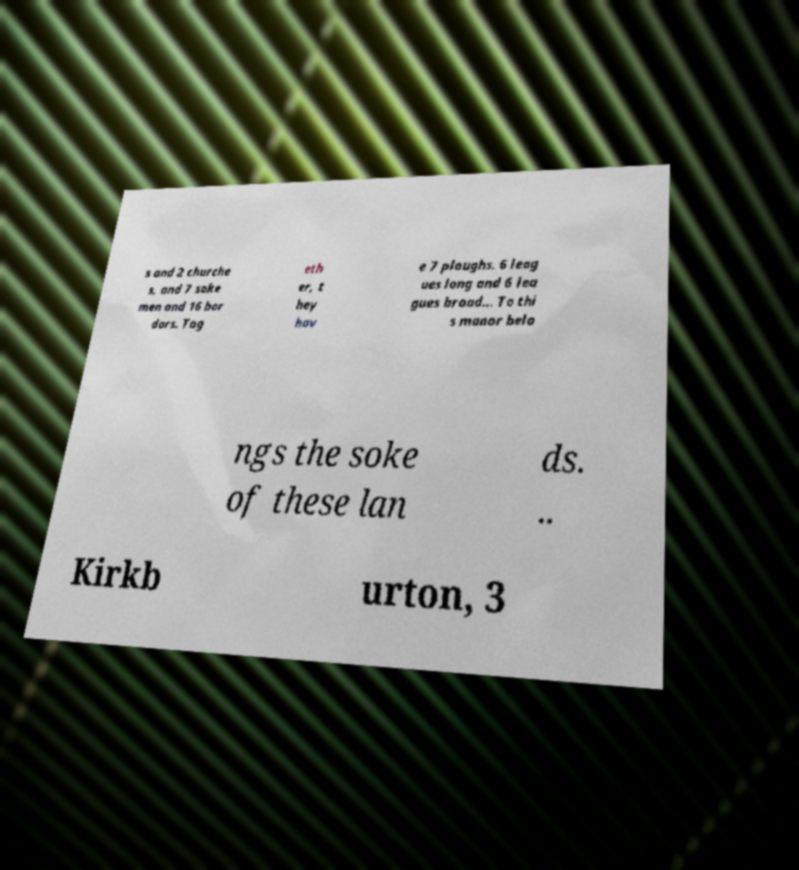There's text embedded in this image that I need extracted. Can you transcribe it verbatim? s and 2 churche s, and 7 soke men and 16 bor dars. Tog eth er, t hey hav e 7 ploughs. 6 leag ues long and 6 lea gues broad... To thi s manor belo ngs the soke of these lan ds. .. Kirkb urton, 3 